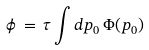Convert formula to latex. <formula><loc_0><loc_0><loc_500><loc_500>\phi \, = \, \tau \int d p _ { 0 } \, \Phi ( p _ { 0 } )</formula> 